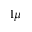Convert formula to latex. <formula><loc_0><loc_0><loc_500><loc_500>1 \mu</formula> 